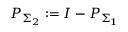Convert formula to latex. <formula><loc_0><loc_0><loc_500><loc_500>P _ { \Sigma _ { 2 } } \colon = I - P _ { \Sigma _ { 1 } }</formula> 